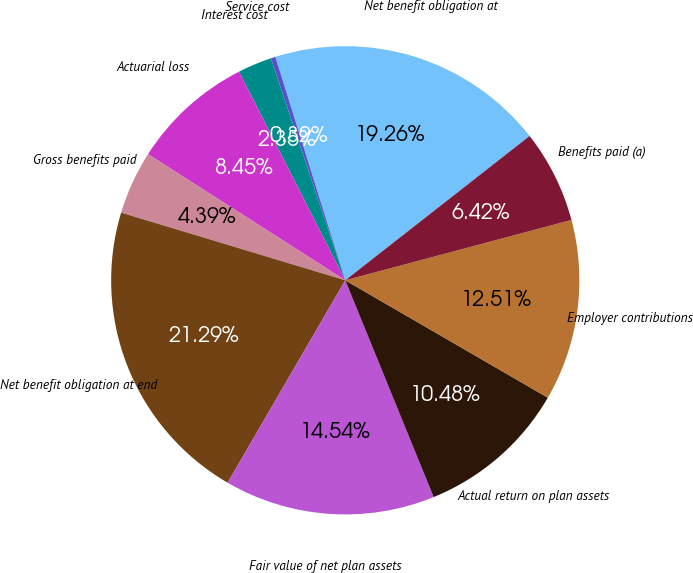Convert chart to OTSL. <chart><loc_0><loc_0><loc_500><loc_500><pie_chart><fcel>Net benefit obligation at<fcel>Service cost<fcel>Interest cost<fcel>Actuarial loss<fcel>Gross benefits paid<fcel>Net benefit obligation at end<fcel>Fair value of net plan assets<fcel>Actual return on plan assets<fcel>Employer contributions<fcel>Benefits paid (a)<nl><fcel>19.26%<fcel>0.32%<fcel>2.35%<fcel>8.45%<fcel>4.39%<fcel>21.29%<fcel>14.54%<fcel>10.48%<fcel>12.51%<fcel>6.42%<nl></chart> 